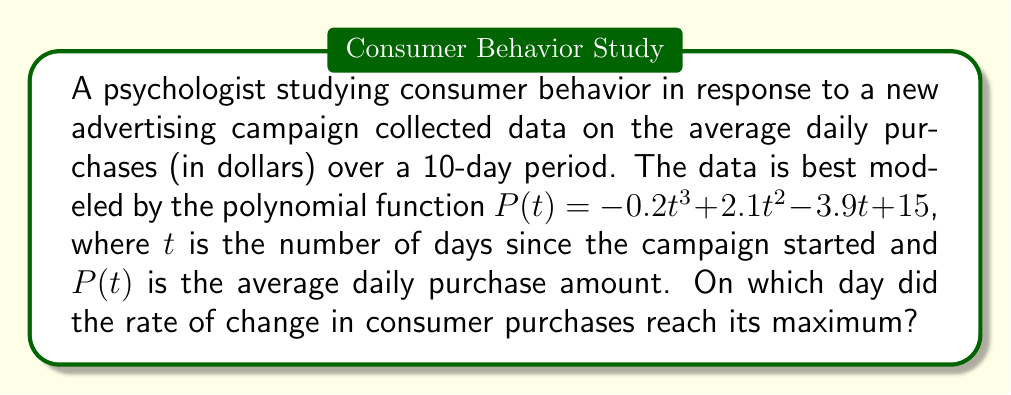Show me your answer to this math problem. To find the day when the rate of change in consumer purchases reached its maximum, we need to follow these steps:

1. The rate of change is given by the first derivative of $P(t)$:
   $$P'(t) = -0.6t^2 + 4.2t - 3.9$$

2. The maximum rate of change occurs when the second derivative equals zero:
   $$P''(t) = -1.2t + 4.2$$
   Set this equal to zero and solve for $t$:
   $$-1.2t + 4.2 = 0$$
   $$-1.2t = -4.2$$
   $$t = 3.5$$

3. To confirm this is a maximum (not a minimum), check that $P'''(t)$ is negative:
   $$P'''(t) = -1.2$$
   Since this is negative, we confirm that $t = 3.5$ gives a maximum rate of change.

4. However, we need to find the day (integer value) when this occurred. Since the rate of change is increasing up to day 3.5 and decreasing after, the maximum integer day will be day 3.
Answer: Day 3 